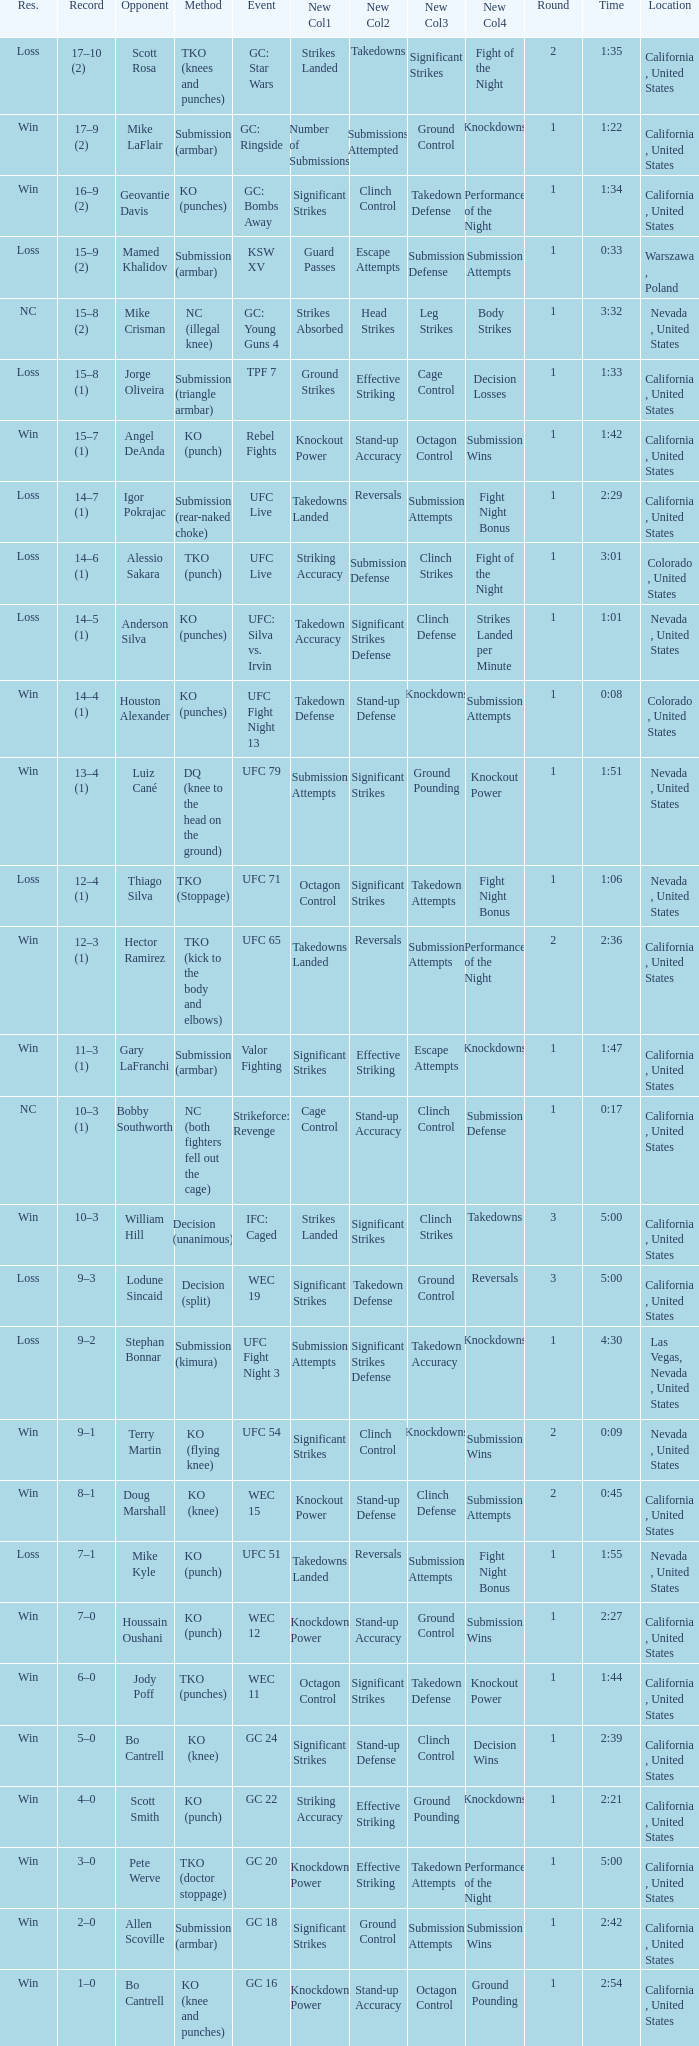What was the method when the time was 1:01? KO (punches). 